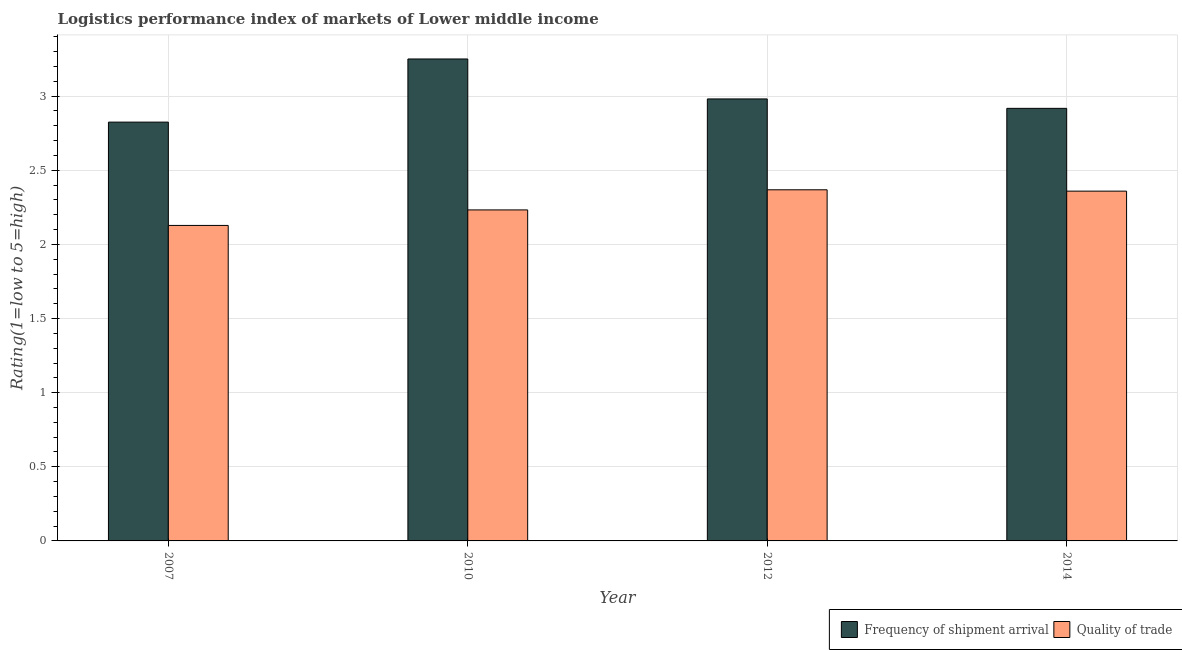How many different coloured bars are there?
Provide a succinct answer. 2. How many groups of bars are there?
Make the answer very short. 4. Are the number of bars on each tick of the X-axis equal?
Give a very brief answer. Yes. How many bars are there on the 1st tick from the left?
Your response must be concise. 2. How many bars are there on the 3rd tick from the right?
Your answer should be compact. 2. What is the label of the 4th group of bars from the left?
Offer a very short reply. 2014. In how many cases, is the number of bars for a given year not equal to the number of legend labels?
Your answer should be very brief. 0. What is the lpi quality of trade in 2012?
Offer a terse response. 2.37. Across all years, what is the maximum lpi quality of trade?
Provide a succinct answer. 2.37. Across all years, what is the minimum lpi of frequency of shipment arrival?
Ensure brevity in your answer.  2.82. In which year was the lpi of frequency of shipment arrival maximum?
Give a very brief answer. 2010. In which year was the lpi of frequency of shipment arrival minimum?
Your answer should be very brief. 2007. What is the total lpi of frequency of shipment arrival in the graph?
Ensure brevity in your answer.  11.97. What is the difference between the lpi quality of trade in 2007 and that in 2014?
Offer a very short reply. -0.23. What is the difference between the lpi quality of trade in 2010 and the lpi of frequency of shipment arrival in 2014?
Make the answer very short. -0.13. What is the average lpi quality of trade per year?
Make the answer very short. 2.27. In the year 2014, what is the difference between the lpi of frequency of shipment arrival and lpi quality of trade?
Your answer should be very brief. 0. In how many years, is the lpi of frequency of shipment arrival greater than 0.5?
Offer a terse response. 4. What is the ratio of the lpi of frequency of shipment arrival in 2012 to that in 2014?
Offer a very short reply. 1.02. Is the difference between the lpi quality of trade in 2007 and 2014 greater than the difference between the lpi of frequency of shipment arrival in 2007 and 2014?
Provide a succinct answer. No. What is the difference between the highest and the second highest lpi quality of trade?
Provide a succinct answer. 0.01. What is the difference between the highest and the lowest lpi quality of trade?
Keep it short and to the point. 0.24. In how many years, is the lpi of frequency of shipment arrival greater than the average lpi of frequency of shipment arrival taken over all years?
Your answer should be compact. 1. What does the 1st bar from the left in 2010 represents?
Offer a very short reply. Frequency of shipment arrival. What does the 2nd bar from the right in 2010 represents?
Make the answer very short. Frequency of shipment arrival. Are all the bars in the graph horizontal?
Provide a succinct answer. No. What is the difference between two consecutive major ticks on the Y-axis?
Make the answer very short. 0.5. Are the values on the major ticks of Y-axis written in scientific E-notation?
Make the answer very short. No. Does the graph contain any zero values?
Give a very brief answer. No. How many legend labels are there?
Your answer should be compact. 2. What is the title of the graph?
Give a very brief answer. Logistics performance index of markets of Lower middle income. What is the label or title of the X-axis?
Provide a short and direct response. Year. What is the label or title of the Y-axis?
Provide a short and direct response. Rating(1=low to 5=high). What is the Rating(1=low to 5=high) in Frequency of shipment arrival in 2007?
Offer a terse response. 2.82. What is the Rating(1=low to 5=high) in Quality of trade in 2007?
Keep it short and to the point. 2.13. What is the Rating(1=low to 5=high) of Frequency of shipment arrival in 2010?
Your answer should be compact. 3.25. What is the Rating(1=low to 5=high) in Quality of trade in 2010?
Make the answer very short. 2.23. What is the Rating(1=low to 5=high) in Frequency of shipment arrival in 2012?
Keep it short and to the point. 2.98. What is the Rating(1=low to 5=high) of Quality of trade in 2012?
Keep it short and to the point. 2.37. What is the Rating(1=low to 5=high) of Frequency of shipment arrival in 2014?
Keep it short and to the point. 2.92. What is the Rating(1=low to 5=high) in Quality of trade in 2014?
Provide a succinct answer. 2.36. Across all years, what is the maximum Rating(1=low to 5=high) of Frequency of shipment arrival?
Your response must be concise. 3.25. Across all years, what is the maximum Rating(1=low to 5=high) of Quality of trade?
Make the answer very short. 2.37. Across all years, what is the minimum Rating(1=low to 5=high) in Frequency of shipment arrival?
Provide a short and direct response. 2.82. Across all years, what is the minimum Rating(1=low to 5=high) of Quality of trade?
Offer a terse response. 2.13. What is the total Rating(1=low to 5=high) of Frequency of shipment arrival in the graph?
Make the answer very short. 11.97. What is the total Rating(1=low to 5=high) of Quality of trade in the graph?
Make the answer very short. 9.09. What is the difference between the Rating(1=low to 5=high) of Frequency of shipment arrival in 2007 and that in 2010?
Give a very brief answer. -0.43. What is the difference between the Rating(1=low to 5=high) of Quality of trade in 2007 and that in 2010?
Offer a terse response. -0.1. What is the difference between the Rating(1=low to 5=high) in Frequency of shipment arrival in 2007 and that in 2012?
Your answer should be compact. -0.16. What is the difference between the Rating(1=low to 5=high) of Quality of trade in 2007 and that in 2012?
Your answer should be compact. -0.24. What is the difference between the Rating(1=low to 5=high) of Frequency of shipment arrival in 2007 and that in 2014?
Make the answer very short. -0.09. What is the difference between the Rating(1=low to 5=high) in Quality of trade in 2007 and that in 2014?
Ensure brevity in your answer.  -0.23. What is the difference between the Rating(1=low to 5=high) of Frequency of shipment arrival in 2010 and that in 2012?
Your response must be concise. 0.27. What is the difference between the Rating(1=low to 5=high) of Quality of trade in 2010 and that in 2012?
Provide a short and direct response. -0.14. What is the difference between the Rating(1=low to 5=high) in Frequency of shipment arrival in 2010 and that in 2014?
Make the answer very short. 0.33. What is the difference between the Rating(1=low to 5=high) of Quality of trade in 2010 and that in 2014?
Offer a terse response. -0.13. What is the difference between the Rating(1=low to 5=high) of Frequency of shipment arrival in 2012 and that in 2014?
Ensure brevity in your answer.  0.06. What is the difference between the Rating(1=low to 5=high) of Quality of trade in 2012 and that in 2014?
Ensure brevity in your answer.  0.01. What is the difference between the Rating(1=low to 5=high) of Frequency of shipment arrival in 2007 and the Rating(1=low to 5=high) of Quality of trade in 2010?
Make the answer very short. 0.59. What is the difference between the Rating(1=low to 5=high) of Frequency of shipment arrival in 2007 and the Rating(1=low to 5=high) of Quality of trade in 2012?
Ensure brevity in your answer.  0.46. What is the difference between the Rating(1=low to 5=high) in Frequency of shipment arrival in 2007 and the Rating(1=low to 5=high) in Quality of trade in 2014?
Offer a terse response. 0.47. What is the difference between the Rating(1=low to 5=high) in Frequency of shipment arrival in 2010 and the Rating(1=low to 5=high) in Quality of trade in 2012?
Your answer should be compact. 0.88. What is the difference between the Rating(1=low to 5=high) in Frequency of shipment arrival in 2010 and the Rating(1=low to 5=high) in Quality of trade in 2014?
Your answer should be compact. 0.89. What is the difference between the Rating(1=low to 5=high) of Frequency of shipment arrival in 2012 and the Rating(1=low to 5=high) of Quality of trade in 2014?
Ensure brevity in your answer.  0.62. What is the average Rating(1=low to 5=high) of Frequency of shipment arrival per year?
Keep it short and to the point. 2.99. What is the average Rating(1=low to 5=high) in Quality of trade per year?
Your answer should be compact. 2.27. In the year 2007, what is the difference between the Rating(1=low to 5=high) in Frequency of shipment arrival and Rating(1=low to 5=high) in Quality of trade?
Your response must be concise. 0.7. In the year 2010, what is the difference between the Rating(1=low to 5=high) of Frequency of shipment arrival and Rating(1=low to 5=high) of Quality of trade?
Provide a succinct answer. 1.02. In the year 2012, what is the difference between the Rating(1=low to 5=high) in Frequency of shipment arrival and Rating(1=low to 5=high) in Quality of trade?
Give a very brief answer. 0.61. In the year 2014, what is the difference between the Rating(1=low to 5=high) in Frequency of shipment arrival and Rating(1=low to 5=high) in Quality of trade?
Provide a short and direct response. 0.56. What is the ratio of the Rating(1=low to 5=high) in Frequency of shipment arrival in 2007 to that in 2010?
Ensure brevity in your answer.  0.87. What is the ratio of the Rating(1=low to 5=high) in Quality of trade in 2007 to that in 2010?
Provide a short and direct response. 0.95. What is the ratio of the Rating(1=low to 5=high) of Frequency of shipment arrival in 2007 to that in 2012?
Offer a very short reply. 0.95. What is the ratio of the Rating(1=low to 5=high) of Quality of trade in 2007 to that in 2012?
Provide a short and direct response. 0.9. What is the ratio of the Rating(1=low to 5=high) in Frequency of shipment arrival in 2007 to that in 2014?
Provide a succinct answer. 0.97. What is the ratio of the Rating(1=low to 5=high) in Quality of trade in 2007 to that in 2014?
Give a very brief answer. 0.9. What is the ratio of the Rating(1=low to 5=high) in Frequency of shipment arrival in 2010 to that in 2012?
Your answer should be very brief. 1.09. What is the ratio of the Rating(1=low to 5=high) of Quality of trade in 2010 to that in 2012?
Your answer should be very brief. 0.94. What is the ratio of the Rating(1=low to 5=high) of Frequency of shipment arrival in 2010 to that in 2014?
Give a very brief answer. 1.11. What is the ratio of the Rating(1=low to 5=high) in Quality of trade in 2010 to that in 2014?
Ensure brevity in your answer.  0.95. What is the ratio of the Rating(1=low to 5=high) of Frequency of shipment arrival in 2012 to that in 2014?
Your answer should be very brief. 1.02. What is the difference between the highest and the second highest Rating(1=low to 5=high) in Frequency of shipment arrival?
Ensure brevity in your answer.  0.27. What is the difference between the highest and the second highest Rating(1=low to 5=high) of Quality of trade?
Keep it short and to the point. 0.01. What is the difference between the highest and the lowest Rating(1=low to 5=high) of Frequency of shipment arrival?
Keep it short and to the point. 0.43. What is the difference between the highest and the lowest Rating(1=low to 5=high) of Quality of trade?
Offer a very short reply. 0.24. 